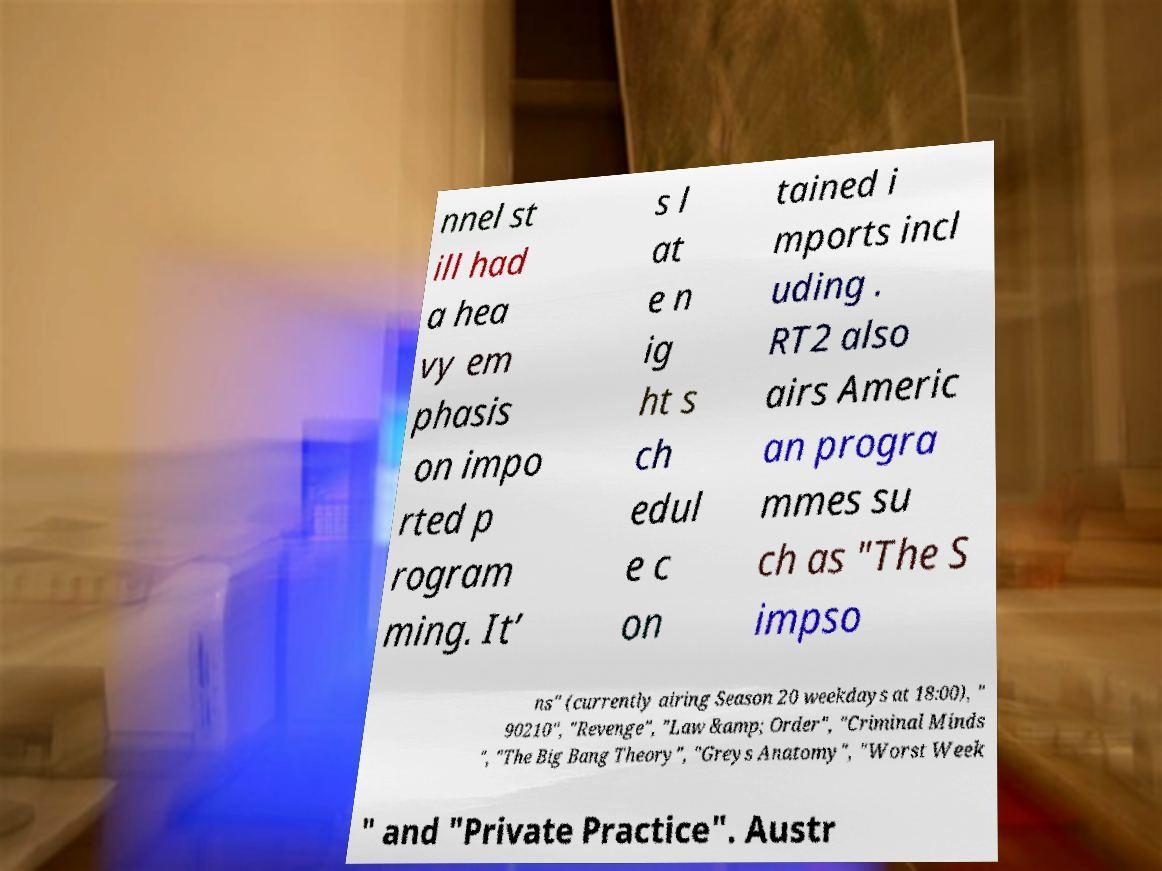Could you extract and type out the text from this image? nnel st ill had a hea vy em phasis on impo rted p rogram ming. It’ s l at e n ig ht s ch edul e c on tained i mports incl uding . RT2 also airs Americ an progra mmes su ch as "The S impso ns" (currently airing Season 20 weekdays at 18:00), " 90210", "Revenge", "Law &amp; Order", "Criminal Minds ", "The Big Bang Theory", "Greys Anatomy", "Worst Week " and "Private Practice". Austr 